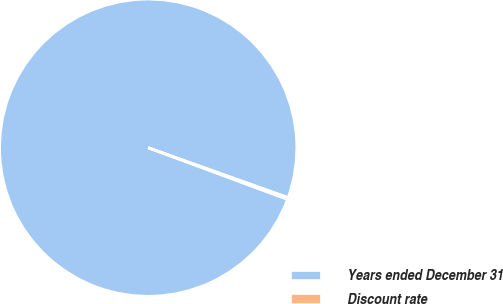<chart> <loc_0><loc_0><loc_500><loc_500><pie_chart><fcel>Years ended December 31<fcel>Discount rate<nl><fcel>99.79%<fcel>0.21%<nl></chart> 